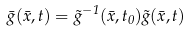<formula> <loc_0><loc_0><loc_500><loc_500>\bar { g } ( \bar { x } , t ) = \tilde { g } ^ { - 1 } ( \bar { x } , t _ { 0 } ) \tilde { g } ( \bar { x } , t )</formula> 